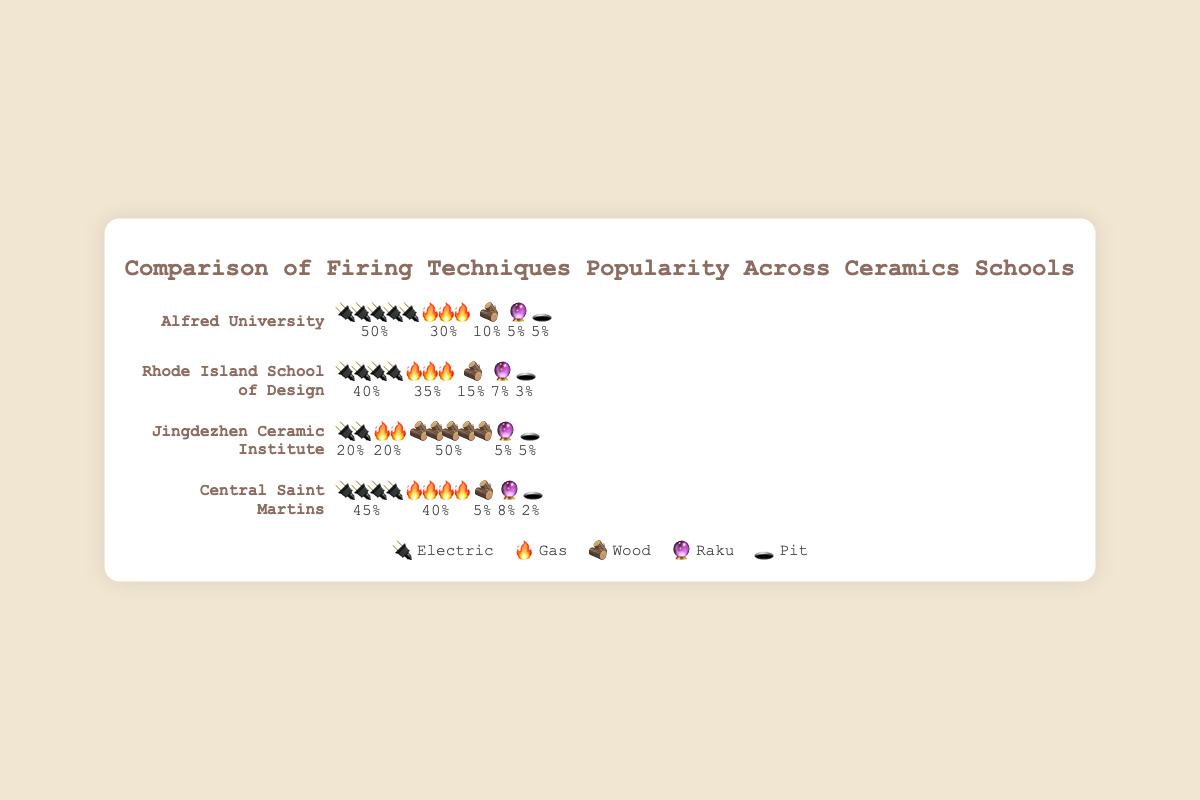What's the most popular firing technique at Alfred University? By looking at the figure, it can be seen that the firing technique with the most icons at Alfred University is electric, represented with 50% 🔌🔌🔌🔌🔌.
Answer: Electric (50%) Which school has the smallest percentage of wood firing usage? By comparing the wood firing percentages across schools, we see that Alfred University and Central Saint Martins both have 5% 🪵.
Answer: Central Saint Martins and Alfred University (5%) How many schools have electric firing as the most popular technique? By checking each school's most prominent icon set for electric firing: Alfred University (50%), Rhode Island School of Design (40%), Central Saint Martins (45%), and Jingdezhen Ceramic Institute (20%). The electric is the most popular in Alfred University, RISD, and Central Saint Martins.
Answer: Three schools Compare the usage of gas firing between Jingdezhen Ceramic Institute and Central Saint Martins. Which one uses it more? Jingdezhen Ceramic Institute has 20% 🔥 🔥 usage while Central Saint Martins has 40% 🔥🔥🔥🔥. Therefore, Central Saint Martins uses gas firing more.
Answer: Central Saint Martins What is the combined percentage of raku firing across all schools? To find the combined percentage, sum the raku firing percentages from each school: Alfred University (5%) + RISD (7%) + Jingdezhen Ceramic Institute (5%) + Central Saint Martins (8%). This results in a total combined percentage of 25%.
Answer: 25% Which school uses pit firing the least and how many percentage points is it? By identifying the least usage of pit firing, we find Central Saint Martins with 2% 🕳️.
Answer: Central Saint Martins (2%) List the schools in descending order of tree firing popularity. By comparing wood firing percentages: Jingdezhen Ceramic Institute (50%), RISD (15%), Alfred University (10%), Central Saint Martins (5%). The order is Jingdezhen Ceramic Institute, RISD, Alfred University, Central Saint Martins.
Answer: Jingdezhen Ceramic Institute, RISD, Alfred University, Central Saint Martins How many schools have at least one firing technique with more than 30% usage? Identify schools with any firing technique exceeding 30%: Alfred University (electric 50%, gas 30%), RISD (electric 40%, gas 35%), Jingdezhen Ceramic Institute (wood 50%), Central Saint Martins (electric 45%, gas 40%). All four schools qualify.
Answer: 4 schools What is the percentage difference between the highest and lowest usage of gas firing? By identifying the highest gas firing usage (Central Saint Martins 40%) and the lowest (Jingdezhen Ceramic Institute 20%), the difference is 40% - 20% = 20%.
Answer: 20% 